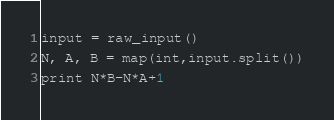Convert code to text. <code><loc_0><loc_0><loc_500><loc_500><_Python_>input = raw_input()
N, A, B = map(int,input.split())
print N*B-N*A+1</code> 